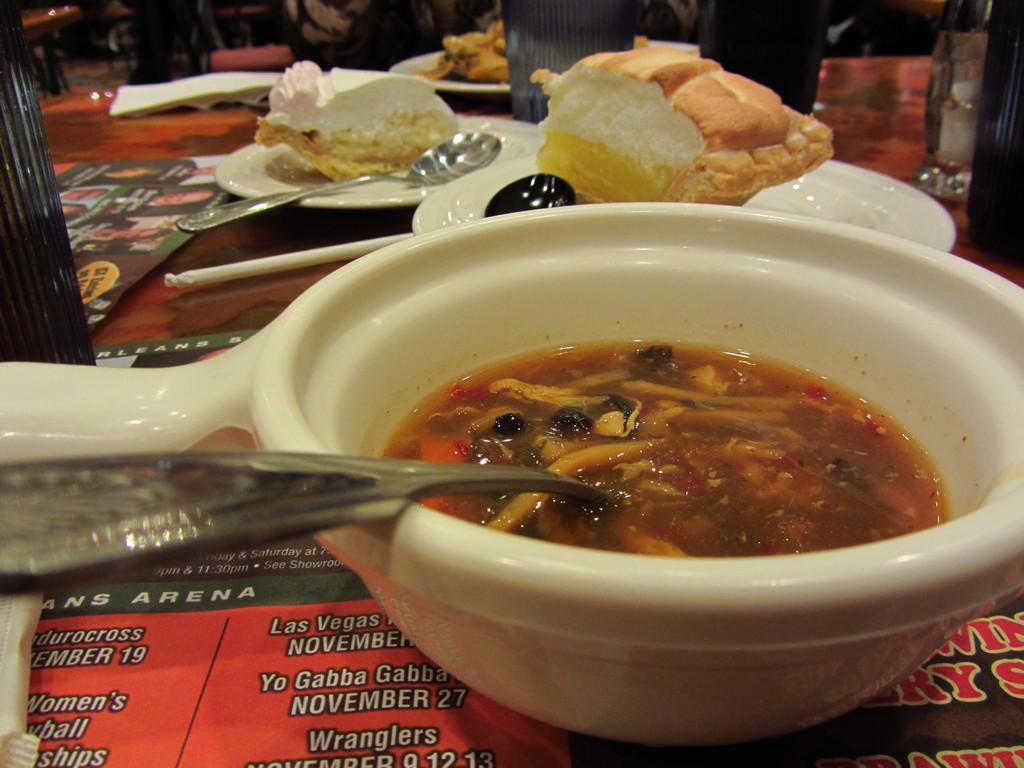Please provide a concise description of this image. This image consists of food which is in the center. There are spoons on the table and there are glasses and there are papers. 